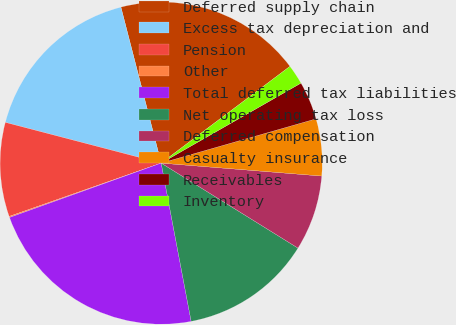<chart> <loc_0><loc_0><loc_500><loc_500><pie_chart><fcel>Deferred supply chain<fcel>Excess tax depreciation and<fcel>Pension<fcel>Other<fcel>Total deferred tax liabilities<fcel>Net operating tax loss<fcel>Deferred compensation<fcel>Casualty insurance<fcel>Receivables<fcel>Inventory<nl><fcel>18.77%<fcel>16.91%<fcel>9.44%<fcel>0.11%<fcel>22.5%<fcel>13.17%<fcel>7.57%<fcel>5.71%<fcel>3.84%<fcel>1.98%<nl></chart> 